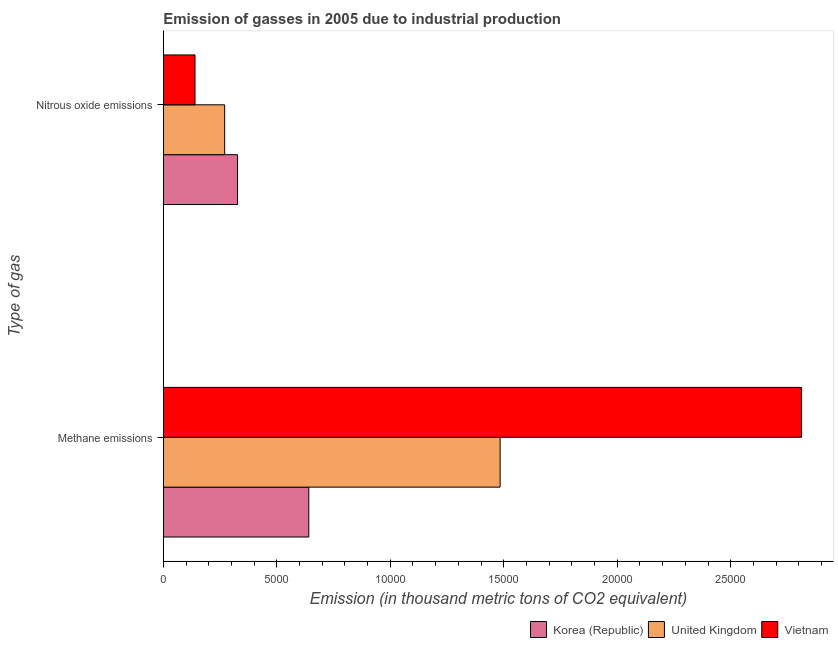How many different coloured bars are there?
Your answer should be compact. 3. How many groups of bars are there?
Offer a terse response. 2. Are the number of bars per tick equal to the number of legend labels?
Offer a very short reply. Yes. How many bars are there on the 2nd tick from the top?
Provide a succinct answer. 3. How many bars are there on the 1st tick from the bottom?
Offer a terse response. 3. What is the label of the 2nd group of bars from the top?
Provide a short and direct response. Methane emissions. What is the amount of methane emissions in Korea (Republic)?
Provide a succinct answer. 6410.4. Across all countries, what is the maximum amount of methane emissions?
Keep it short and to the point. 2.81e+04. Across all countries, what is the minimum amount of methane emissions?
Offer a very short reply. 6410.4. In which country was the amount of nitrous oxide emissions maximum?
Make the answer very short. Korea (Republic). What is the total amount of methane emissions in the graph?
Give a very brief answer. 4.94e+04. What is the difference between the amount of nitrous oxide emissions in Korea (Republic) and that in United Kingdom?
Provide a short and direct response. 567.6. What is the difference between the amount of methane emissions in Korea (Republic) and the amount of nitrous oxide emissions in Vietnam?
Ensure brevity in your answer.  5014. What is the average amount of nitrous oxide emissions per country?
Give a very brief answer. 2457.6. What is the difference between the amount of methane emissions and amount of nitrous oxide emissions in United Kingdom?
Your response must be concise. 1.21e+04. What is the ratio of the amount of nitrous oxide emissions in Vietnam to that in United Kingdom?
Offer a very short reply. 0.52. In how many countries, is the amount of methane emissions greater than the average amount of methane emissions taken over all countries?
Provide a short and direct response. 1. What does the 1st bar from the top in Nitrous oxide emissions represents?
Provide a short and direct response. Vietnam. What does the 3rd bar from the bottom in Methane emissions represents?
Your response must be concise. Vietnam. How many bars are there?
Provide a short and direct response. 6. Are all the bars in the graph horizontal?
Give a very brief answer. Yes. How many countries are there in the graph?
Your answer should be very brief. 3. Where does the legend appear in the graph?
Make the answer very short. Bottom right. How many legend labels are there?
Ensure brevity in your answer.  3. How are the legend labels stacked?
Give a very brief answer. Horizontal. What is the title of the graph?
Make the answer very short. Emission of gasses in 2005 due to industrial production. Does "Saudi Arabia" appear as one of the legend labels in the graph?
Provide a succinct answer. No. What is the label or title of the X-axis?
Provide a short and direct response. Emission (in thousand metric tons of CO2 equivalent). What is the label or title of the Y-axis?
Ensure brevity in your answer.  Type of gas. What is the Emission (in thousand metric tons of CO2 equivalent) in Korea (Republic) in Methane emissions?
Your answer should be compact. 6410.4. What is the Emission (in thousand metric tons of CO2 equivalent) of United Kingdom in Methane emissions?
Provide a short and direct response. 1.48e+04. What is the Emission (in thousand metric tons of CO2 equivalent) in Vietnam in Methane emissions?
Offer a terse response. 2.81e+04. What is the Emission (in thousand metric tons of CO2 equivalent) in Korea (Republic) in Nitrous oxide emissions?
Offer a terse response. 3272. What is the Emission (in thousand metric tons of CO2 equivalent) in United Kingdom in Nitrous oxide emissions?
Your answer should be very brief. 2704.4. What is the Emission (in thousand metric tons of CO2 equivalent) in Vietnam in Nitrous oxide emissions?
Provide a short and direct response. 1396.4. Across all Type of gas, what is the maximum Emission (in thousand metric tons of CO2 equivalent) in Korea (Republic)?
Make the answer very short. 6410.4. Across all Type of gas, what is the maximum Emission (in thousand metric tons of CO2 equivalent) of United Kingdom?
Ensure brevity in your answer.  1.48e+04. Across all Type of gas, what is the maximum Emission (in thousand metric tons of CO2 equivalent) of Vietnam?
Provide a succinct answer. 2.81e+04. Across all Type of gas, what is the minimum Emission (in thousand metric tons of CO2 equivalent) of Korea (Republic)?
Give a very brief answer. 3272. Across all Type of gas, what is the minimum Emission (in thousand metric tons of CO2 equivalent) in United Kingdom?
Your answer should be very brief. 2704.4. Across all Type of gas, what is the minimum Emission (in thousand metric tons of CO2 equivalent) in Vietnam?
Your answer should be compact. 1396.4. What is the total Emission (in thousand metric tons of CO2 equivalent) in Korea (Republic) in the graph?
Your response must be concise. 9682.4. What is the total Emission (in thousand metric tons of CO2 equivalent) in United Kingdom in the graph?
Make the answer very short. 1.75e+04. What is the total Emission (in thousand metric tons of CO2 equivalent) in Vietnam in the graph?
Offer a terse response. 2.95e+04. What is the difference between the Emission (in thousand metric tons of CO2 equivalent) of Korea (Republic) in Methane emissions and that in Nitrous oxide emissions?
Ensure brevity in your answer.  3138.4. What is the difference between the Emission (in thousand metric tons of CO2 equivalent) in United Kingdom in Methane emissions and that in Nitrous oxide emissions?
Keep it short and to the point. 1.21e+04. What is the difference between the Emission (in thousand metric tons of CO2 equivalent) in Vietnam in Methane emissions and that in Nitrous oxide emissions?
Ensure brevity in your answer.  2.67e+04. What is the difference between the Emission (in thousand metric tons of CO2 equivalent) in Korea (Republic) in Methane emissions and the Emission (in thousand metric tons of CO2 equivalent) in United Kingdom in Nitrous oxide emissions?
Offer a terse response. 3706. What is the difference between the Emission (in thousand metric tons of CO2 equivalent) of Korea (Republic) in Methane emissions and the Emission (in thousand metric tons of CO2 equivalent) of Vietnam in Nitrous oxide emissions?
Your answer should be very brief. 5014. What is the difference between the Emission (in thousand metric tons of CO2 equivalent) in United Kingdom in Methane emissions and the Emission (in thousand metric tons of CO2 equivalent) in Vietnam in Nitrous oxide emissions?
Your answer should be very brief. 1.34e+04. What is the average Emission (in thousand metric tons of CO2 equivalent) of Korea (Republic) per Type of gas?
Keep it short and to the point. 4841.2. What is the average Emission (in thousand metric tons of CO2 equivalent) of United Kingdom per Type of gas?
Offer a terse response. 8772.05. What is the average Emission (in thousand metric tons of CO2 equivalent) in Vietnam per Type of gas?
Make the answer very short. 1.48e+04. What is the difference between the Emission (in thousand metric tons of CO2 equivalent) in Korea (Republic) and Emission (in thousand metric tons of CO2 equivalent) in United Kingdom in Methane emissions?
Offer a very short reply. -8429.3. What is the difference between the Emission (in thousand metric tons of CO2 equivalent) of Korea (Republic) and Emission (in thousand metric tons of CO2 equivalent) of Vietnam in Methane emissions?
Offer a terse response. -2.17e+04. What is the difference between the Emission (in thousand metric tons of CO2 equivalent) in United Kingdom and Emission (in thousand metric tons of CO2 equivalent) in Vietnam in Methane emissions?
Your answer should be compact. -1.33e+04. What is the difference between the Emission (in thousand metric tons of CO2 equivalent) in Korea (Republic) and Emission (in thousand metric tons of CO2 equivalent) in United Kingdom in Nitrous oxide emissions?
Your answer should be very brief. 567.6. What is the difference between the Emission (in thousand metric tons of CO2 equivalent) in Korea (Republic) and Emission (in thousand metric tons of CO2 equivalent) in Vietnam in Nitrous oxide emissions?
Ensure brevity in your answer.  1875.6. What is the difference between the Emission (in thousand metric tons of CO2 equivalent) of United Kingdom and Emission (in thousand metric tons of CO2 equivalent) of Vietnam in Nitrous oxide emissions?
Keep it short and to the point. 1308. What is the ratio of the Emission (in thousand metric tons of CO2 equivalent) of Korea (Republic) in Methane emissions to that in Nitrous oxide emissions?
Make the answer very short. 1.96. What is the ratio of the Emission (in thousand metric tons of CO2 equivalent) of United Kingdom in Methane emissions to that in Nitrous oxide emissions?
Give a very brief answer. 5.49. What is the ratio of the Emission (in thousand metric tons of CO2 equivalent) in Vietnam in Methane emissions to that in Nitrous oxide emissions?
Give a very brief answer. 20.14. What is the difference between the highest and the second highest Emission (in thousand metric tons of CO2 equivalent) in Korea (Republic)?
Offer a very short reply. 3138.4. What is the difference between the highest and the second highest Emission (in thousand metric tons of CO2 equivalent) of United Kingdom?
Your response must be concise. 1.21e+04. What is the difference between the highest and the second highest Emission (in thousand metric tons of CO2 equivalent) in Vietnam?
Ensure brevity in your answer.  2.67e+04. What is the difference between the highest and the lowest Emission (in thousand metric tons of CO2 equivalent) of Korea (Republic)?
Keep it short and to the point. 3138.4. What is the difference between the highest and the lowest Emission (in thousand metric tons of CO2 equivalent) in United Kingdom?
Keep it short and to the point. 1.21e+04. What is the difference between the highest and the lowest Emission (in thousand metric tons of CO2 equivalent) of Vietnam?
Give a very brief answer. 2.67e+04. 